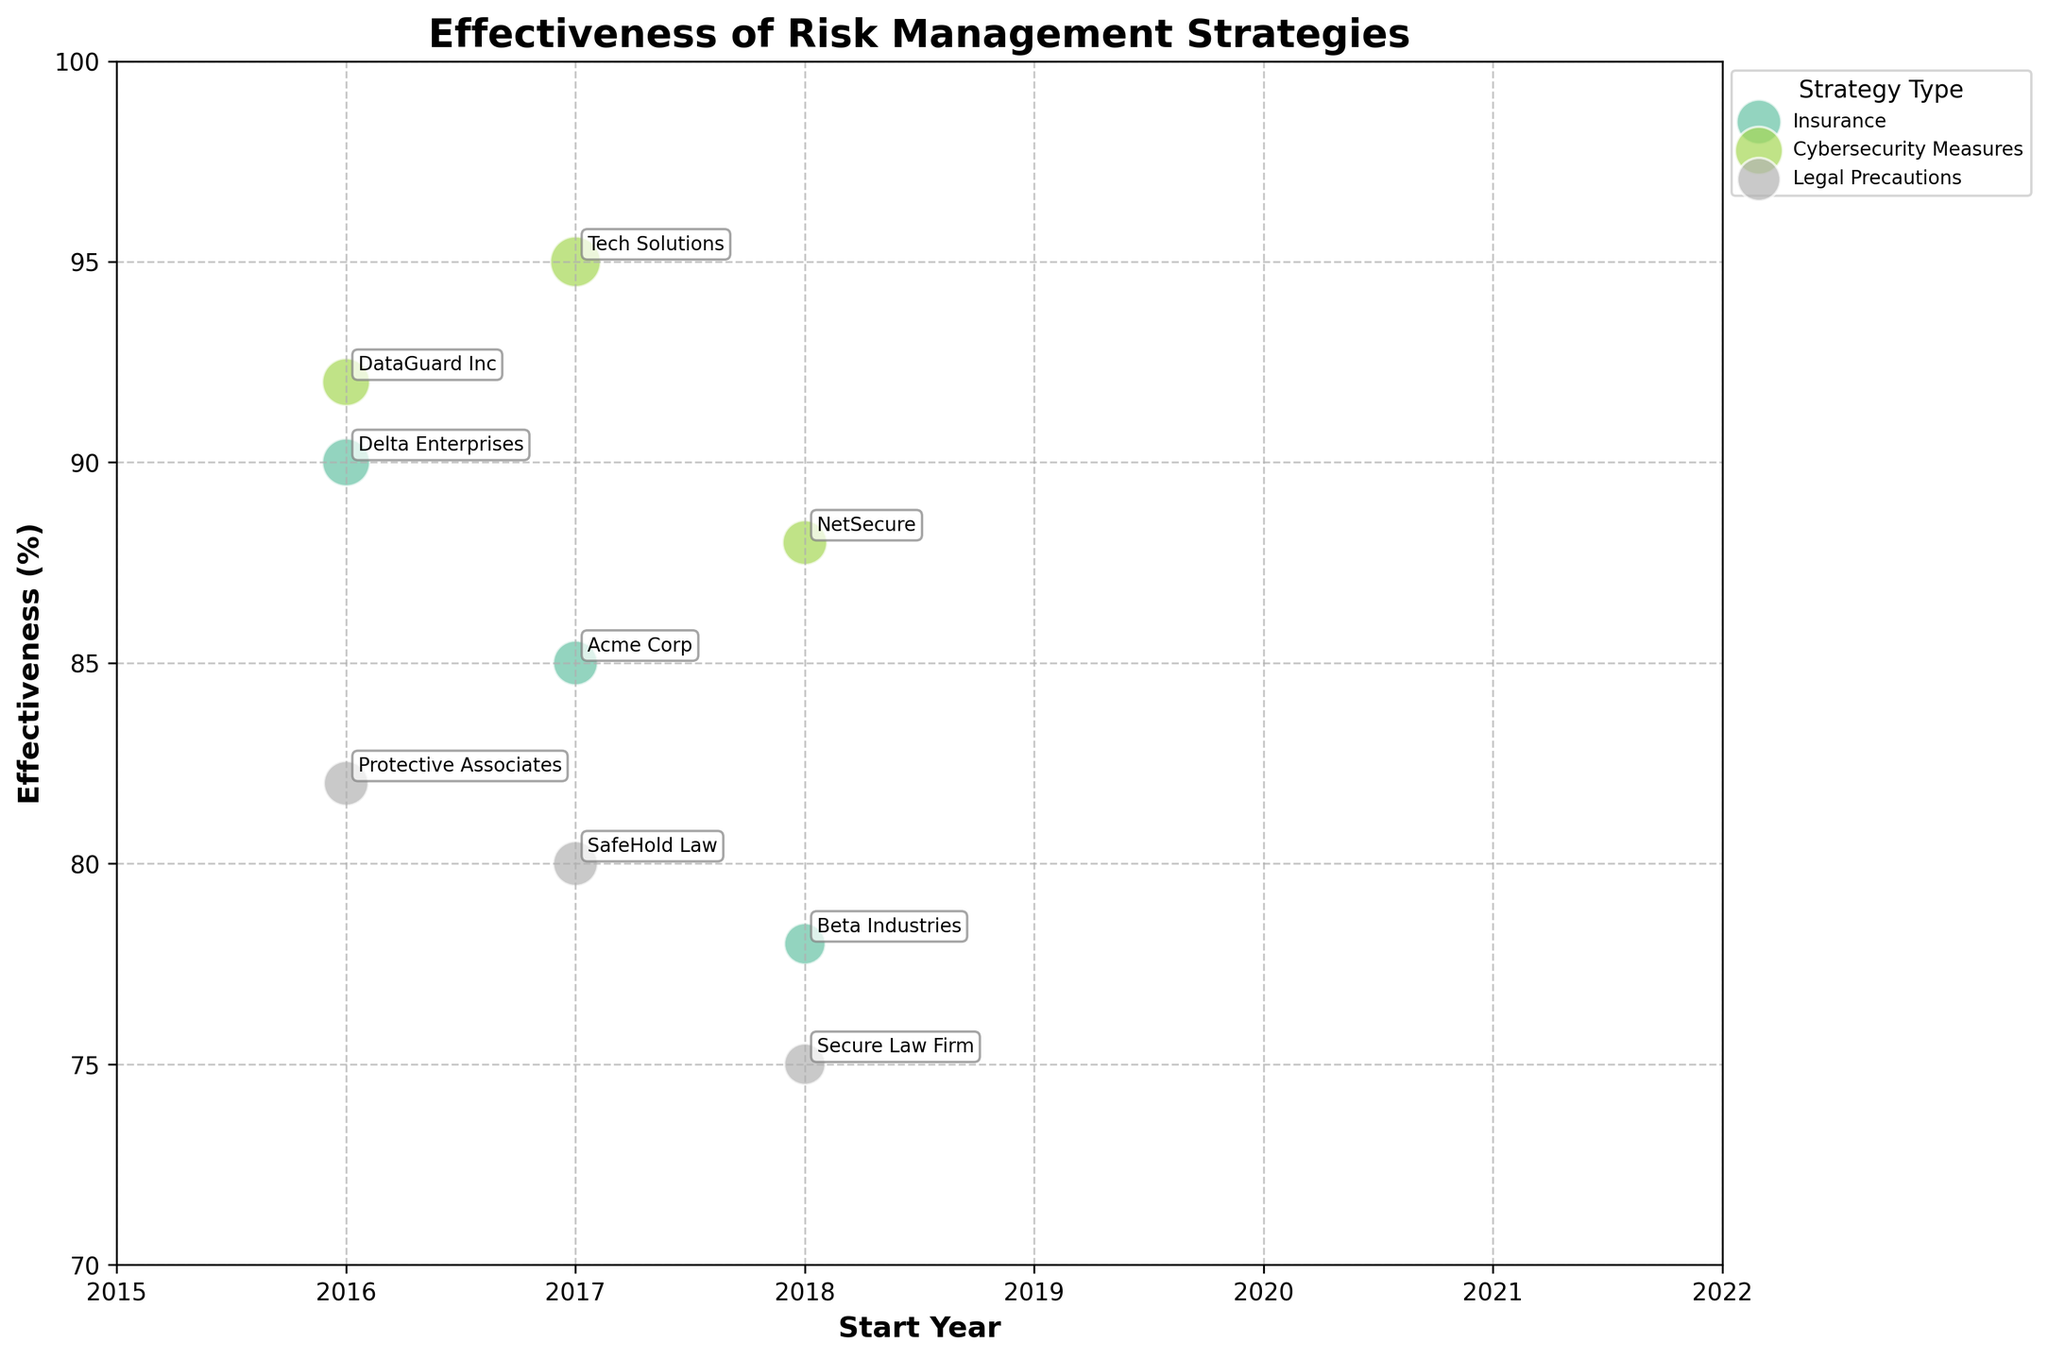What is the title of the figure? The title of the figure is located at the top and summarizes the overall content of the chart. The title is "Effectiveness of Risk Management Strategies."
Answer: Effectiveness of Risk Management Strategies What is the effectiveness percentage of the Tech Solutions entity? Look for the bubble associated with "Tech Solutions" in the "Cybersecurity Measures" strategy type. The effectiveness percentage for Tech Solutions is annotated next to this bubble, which is 95%.
Answer: 95 Which entity showed the highest impact scale? Find the largest bubble in the chart by checking the size of each bubble. The largest bubble (size = 450) belongs to "Tech Solutions" under the "Cybersecurity Measures" strategy type. The impact scale for Tech Solutions is 9, which is the highest.
Answer: Tech Solutions During which time period did DataGuard Inc demonstrate its effectiveness? Locate the bubble for "DataGuard Inc" in the "Cybersecurity Measures" strategy type. The time period annotated next to this bubble is 2016-2020.
Answer: 2016-2020 How many entities used the "Insurance" strategy type and what are their names? Count the number of bubbles associated with the "Insurance" strategy type. There are three bubbles, and the entities are "Acme Corp," "Beta Industries," and "Delta Enterprises."
Answer: Three, "Acme Corp," "Beta Industries," and "Delta Enterprises." What is the start year for the majority of the strategies analyzed? Analyze the start years listed for each entity in the chart. The start years are: 2017, 2018, 2016, 2017, 2018, 2016, 2017, 2018, 2016. The most frequent start year is 2017.
Answer: 2017 Which strategy type overall showed the least effectiveness based on visual observation? Based on the chart, visually identify that the "Legal Precautions" strategy type has lower bubble positions compared to "Insurance" and "Cybersecurity Measures," indicating it has the lowest overall effectiveness.
Answer: Legal Precautions 